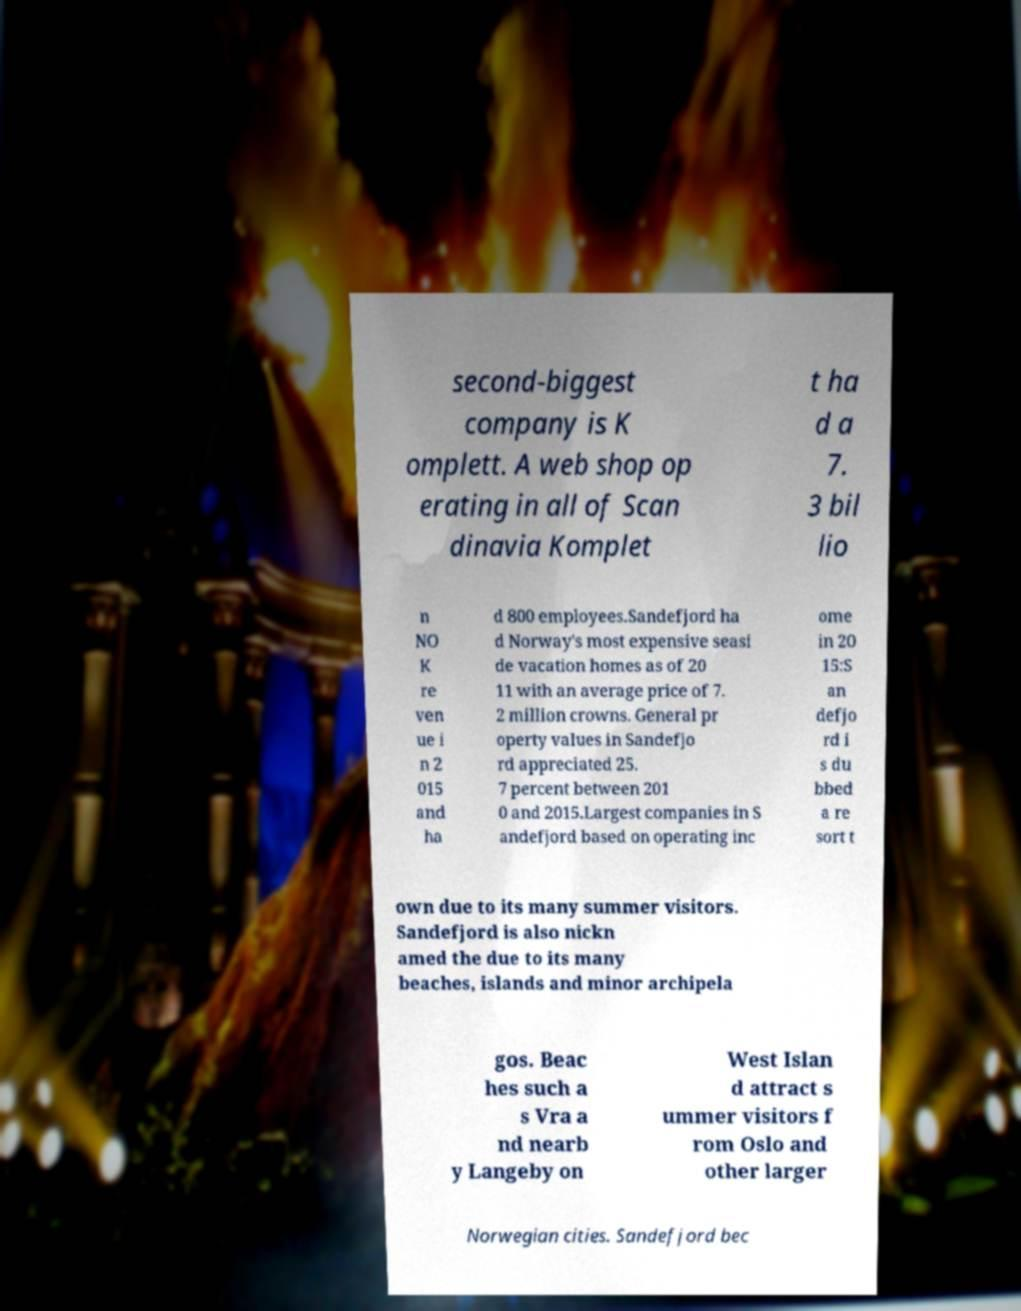Can you read and provide the text displayed in the image?This photo seems to have some interesting text. Can you extract and type it out for me? second-biggest company is K omplett. A web shop op erating in all of Scan dinavia Komplet t ha d a 7. 3 bil lio n NO K re ven ue i n 2 015 and ha d 800 employees.Sandefjord ha d Norway's most expensive seasi de vacation homes as of 20 11 with an average price of 7. 2 million crowns. General pr operty values in Sandefjo rd appreciated 25. 7 percent between 201 0 and 2015.Largest companies in S andefjord based on operating inc ome in 20 15:S an defjo rd i s du bbed a re sort t own due to its many summer visitors. Sandefjord is also nickn amed the due to its many beaches, islands and minor archipela gos. Beac hes such a s Vra a nd nearb y Langeby on West Islan d attract s ummer visitors f rom Oslo and other larger Norwegian cities. Sandefjord bec 